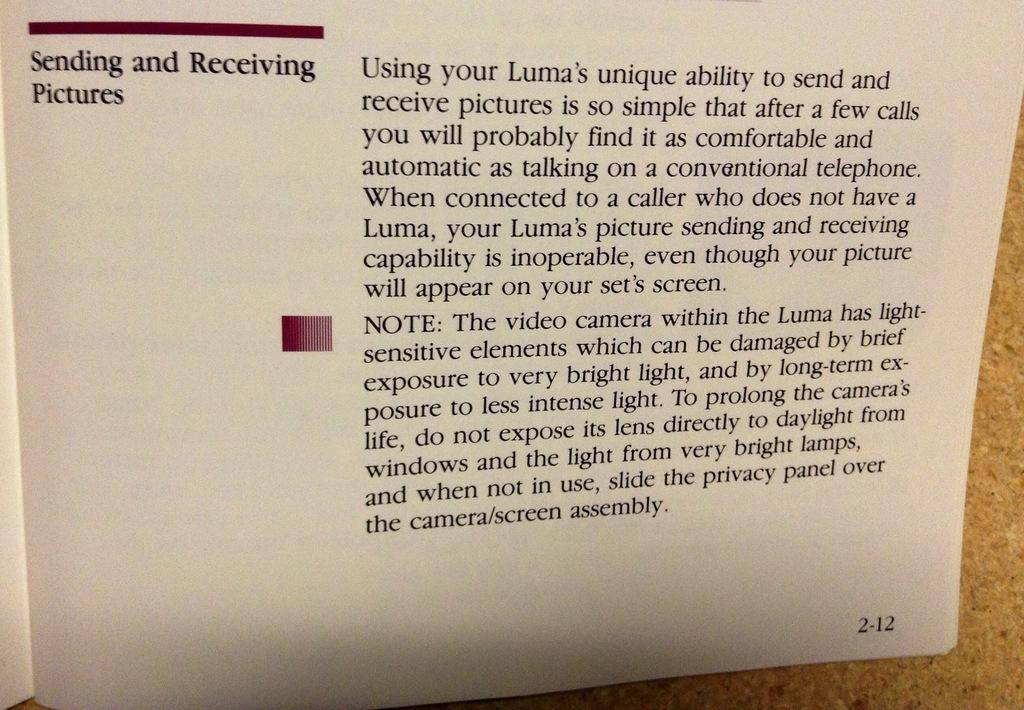<image>
Summarize the visual content of the image. A page from a book that says sending and receiving pictures 